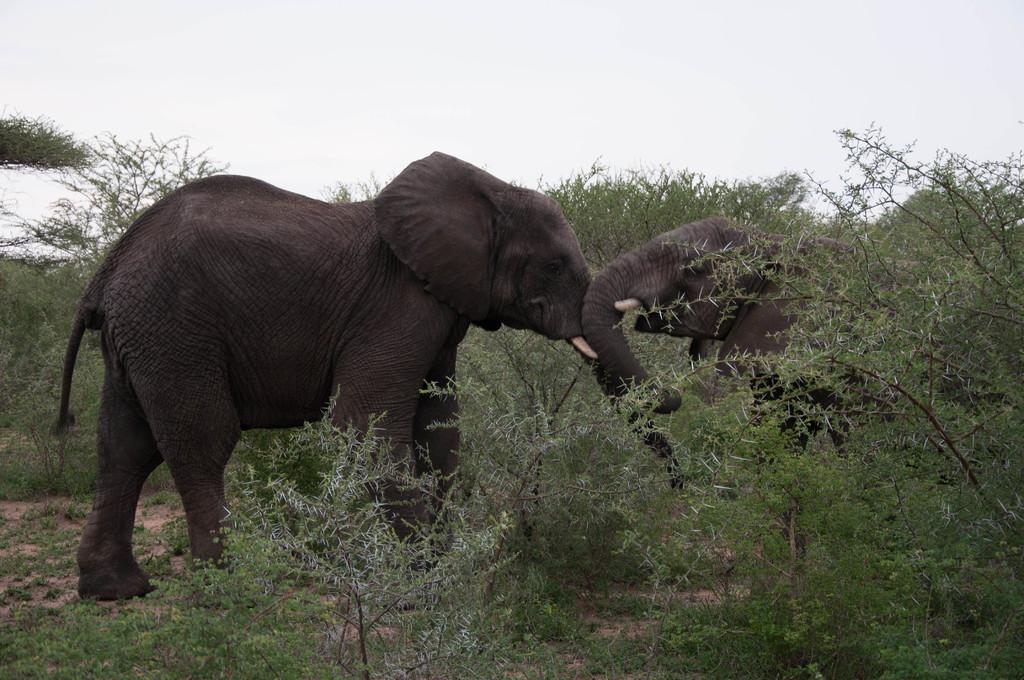What type of vegetation is present in the image? There is grass in the image. How many elephants can be seen in the image? There are two elephants in the image. What other natural elements are visible in the image? There are trees in the image. What can be seen in the distance in the image? The sky is visible in the background of the image. What type of dinner is being served to the elephants in the image? There is no dinner being served to the elephants in the image; the focus is on the grass, trees, and sky. 